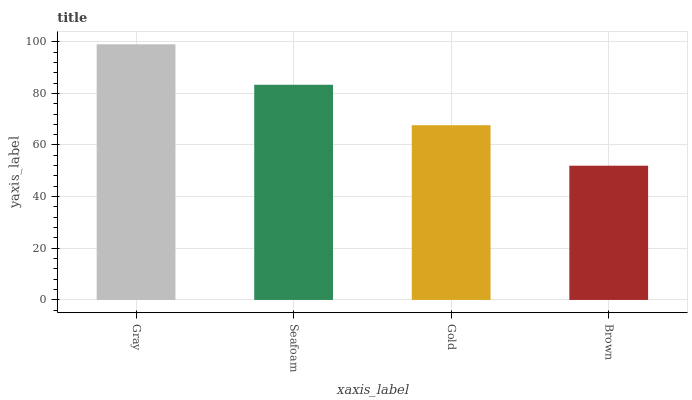Is Brown the minimum?
Answer yes or no. Yes. Is Gray the maximum?
Answer yes or no. Yes. Is Seafoam the minimum?
Answer yes or no. No. Is Seafoam the maximum?
Answer yes or no. No. Is Gray greater than Seafoam?
Answer yes or no. Yes. Is Seafoam less than Gray?
Answer yes or no. Yes. Is Seafoam greater than Gray?
Answer yes or no. No. Is Gray less than Seafoam?
Answer yes or no. No. Is Seafoam the high median?
Answer yes or no. Yes. Is Gold the low median?
Answer yes or no. Yes. Is Gray the high median?
Answer yes or no. No. Is Gray the low median?
Answer yes or no. No. 